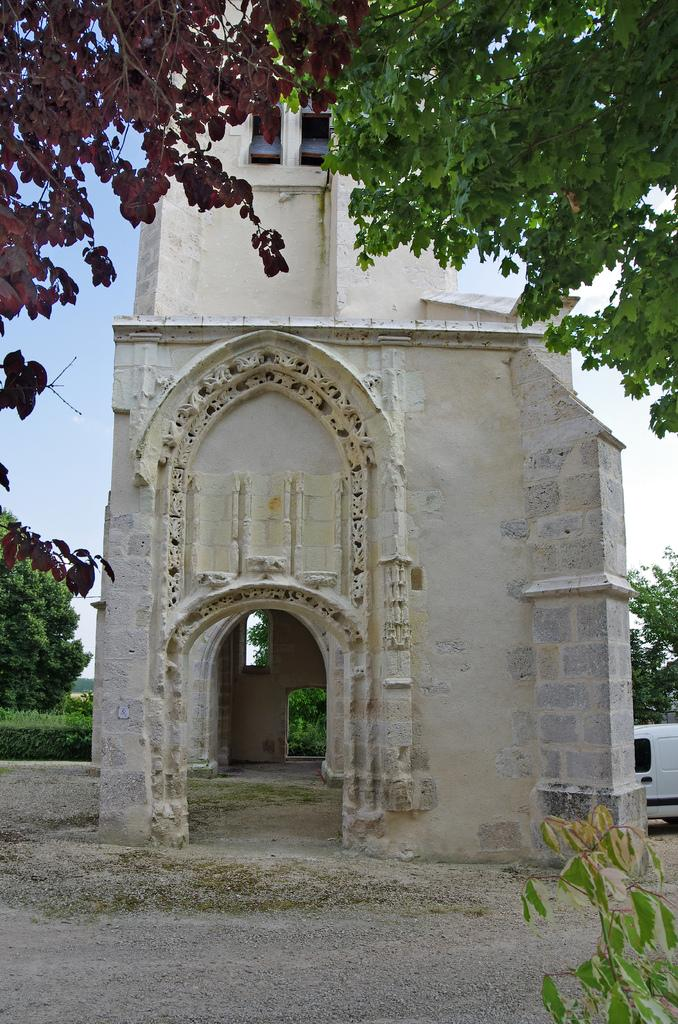What is the main structure in the picture? There is a building in the picture. What is the color of the building? The building is white. What other natural elements can be seen in the picture? There are trees in the picture. What is visible in the background of the picture? The sky is visible in the background of the picture. How many legs can be seen supporting the building in the image? There are no legs visible supporting the building in the image; it is a solid structure. What type of gold object is present in the image? There is no gold object present in the image. 